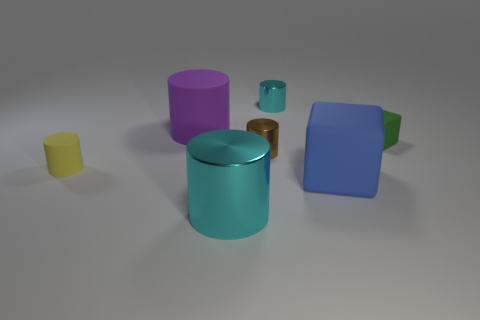The metallic object that is the same color as the large shiny cylinder is what size?
Provide a short and direct response. Small. What number of small cyan metallic cylinders are in front of the blue thing?
Keep it short and to the point. 0. There is a cyan shiny cylinder behind the matte block on the left side of the matte cube that is behind the small yellow rubber thing; how big is it?
Offer a terse response. Small. Is there a tiny brown cylinder that is in front of the cyan metal object in front of the small cylinder behind the large rubber cylinder?
Your response must be concise. No. Is the number of blue matte blocks greater than the number of small gray cylinders?
Keep it short and to the point. Yes. What is the color of the big thing that is behind the yellow matte thing?
Ensure brevity in your answer.  Purple. Is the number of big blue blocks that are behind the brown metallic cylinder greater than the number of small brown cylinders?
Ensure brevity in your answer.  No. Is the tiny green thing made of the same material as the large cyan object?
Give a very brief answer. No. What number of other things are the same shape as the small yellow rubber object?
Offer a very short reply. 4. Is there anything else that is made of the same material as the tiny block?
Ensure brevity in your answer.  Yes. 